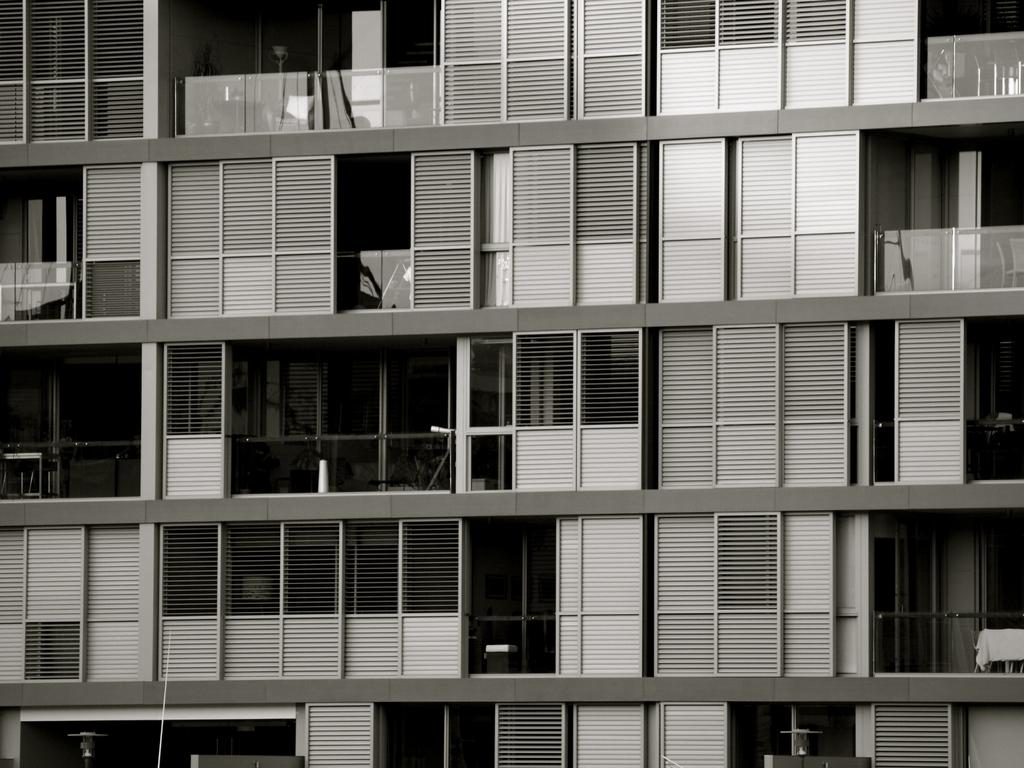What type of structure is visible in the image? There is a building in the image. What type of doors can be seen on the building? There are glass doors in the image. What color scheme is used in the image? The image is black and white. What type of wood is used to construct the chair in the image? There is no chair present in the image, so it is not possible to determine the type of wood used. 